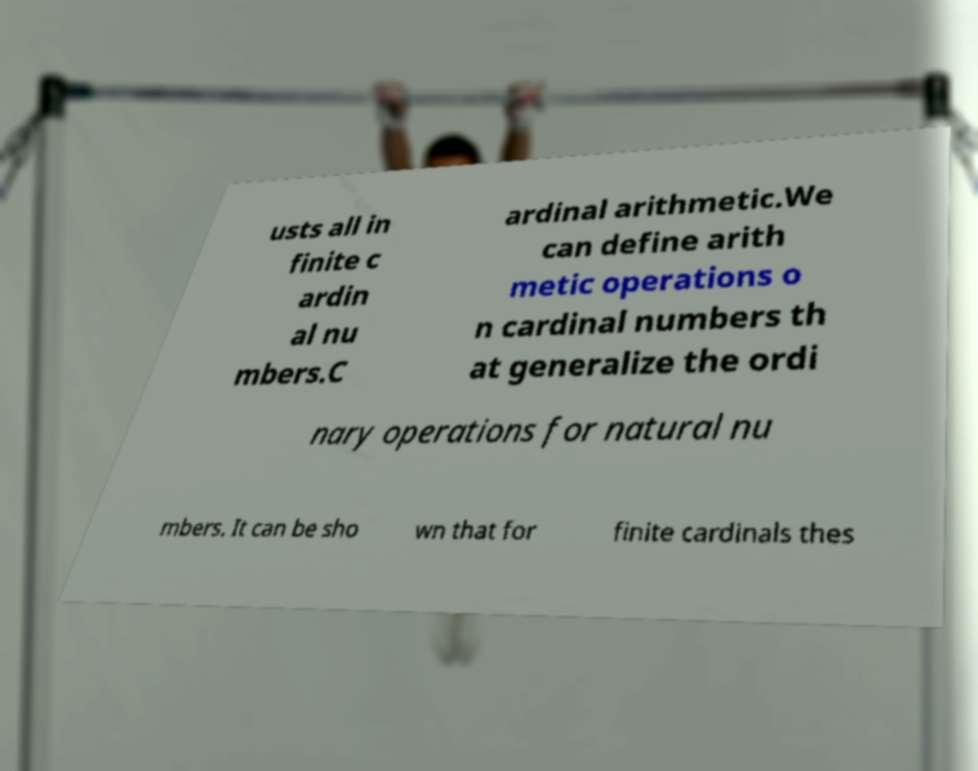Can you accurately transcribe the text from the provided image for me? usts all in finite c ardin al nu mbers.C ardinal arithmetic.We can define arith metic operations o n cardinal numbers th at generalize the ordi nary operations for natural nu mbers. It can be sho wn that for finite cardinals thes 